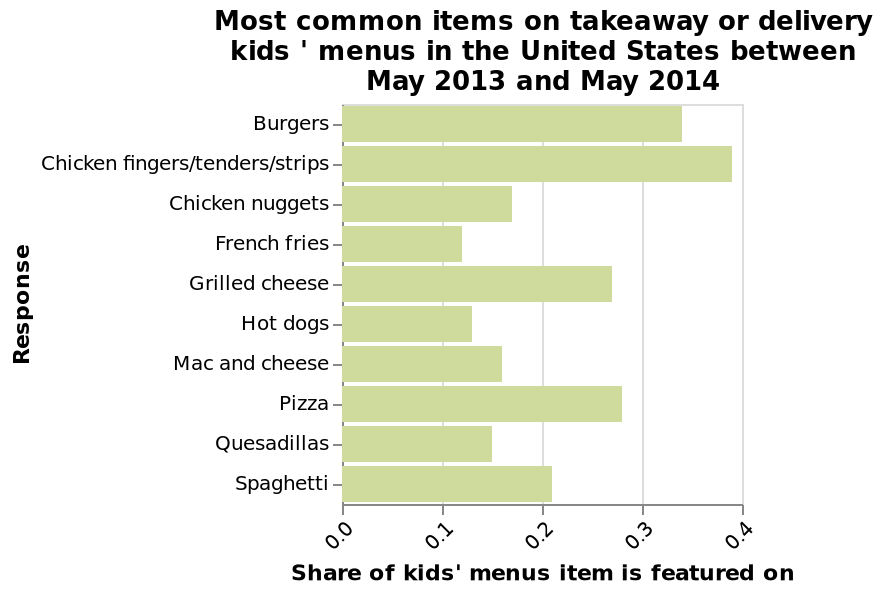<image>
What is the categorical scale on the y-axis of the bar diagram?  The categorical scale on the y-axis of the bar diagram is labeled Most common items on takeaway or delivery kids' menus in the United States between May 2013 and May 2014. What is the market share of pizza in the kid delivery/takeaway market?  Pizza has a market share of around 0.28. What is the market share of chicken fingers in the kid delivery/takeaway market?  The market share of chicken fingers is almost 0.4. please describe the details of the chart This is a bar diagram labeled Most common items on takeaway or delivery kids ' menus in the United States between May 2013 and May 2014. There is a categorical scale starting with Burgers and ending with Spaghetti along the y-axis, marked Response. There is a linear scale from 0.0 to 0.4 on the x-axis, marked Share of kids' menus item is featured on. 